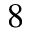<formula> <loc_0><loc_0><loc_500><loc_500>8</formula> 